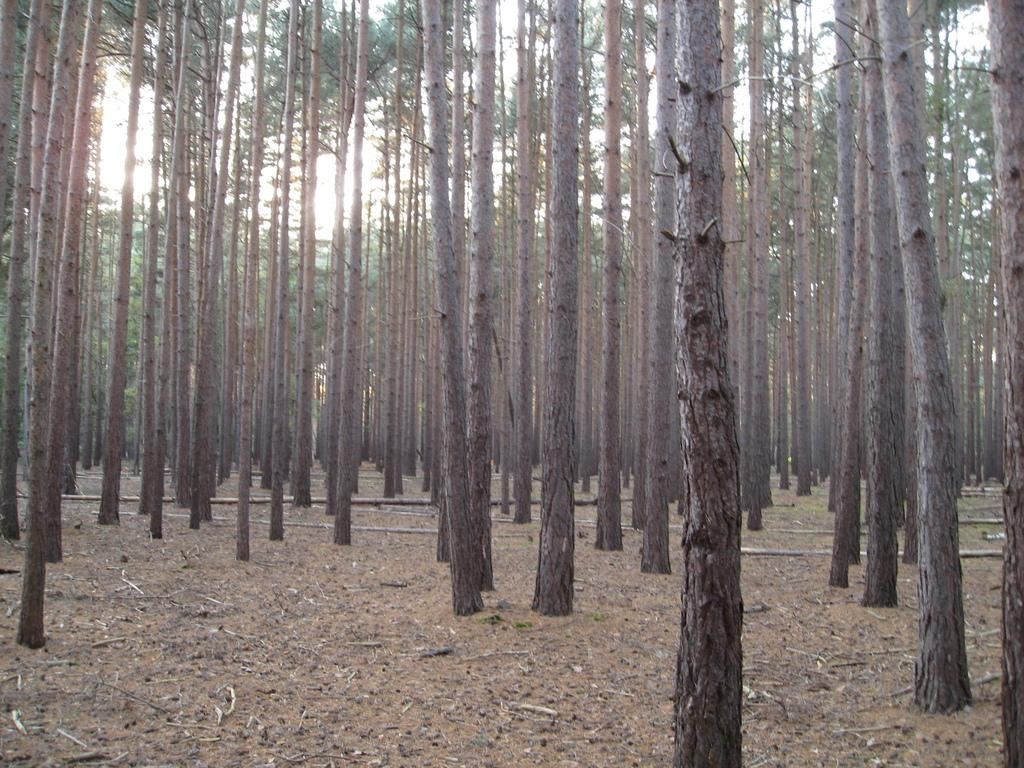What part of the natural environment is visible in the image? Sky, trees, and ground are visible in the image. What type of vegetation can be seen in the image? Trees and twigs are visible in the image. How many fish can be seen swimming in the image? There are no fish present in the image. What type of yam is being used as a prop in the image? There is no yam present in the image. 